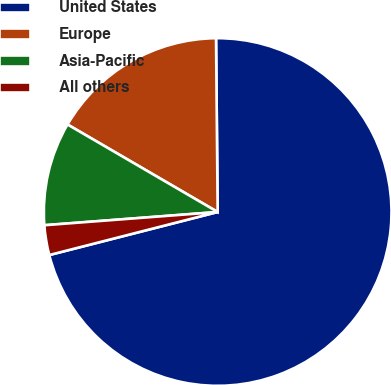Convert chart. <chart><loc_0><loc_0><loc_500><loc_500><pie_chart><fcel>United States<fcel>Europe<fcel>Asia-Pacific<fcel>All others<nl><fcel>71.16%<fcel>16.45%<fcel>9.61%<fcel>2.77%<nl></chart> 